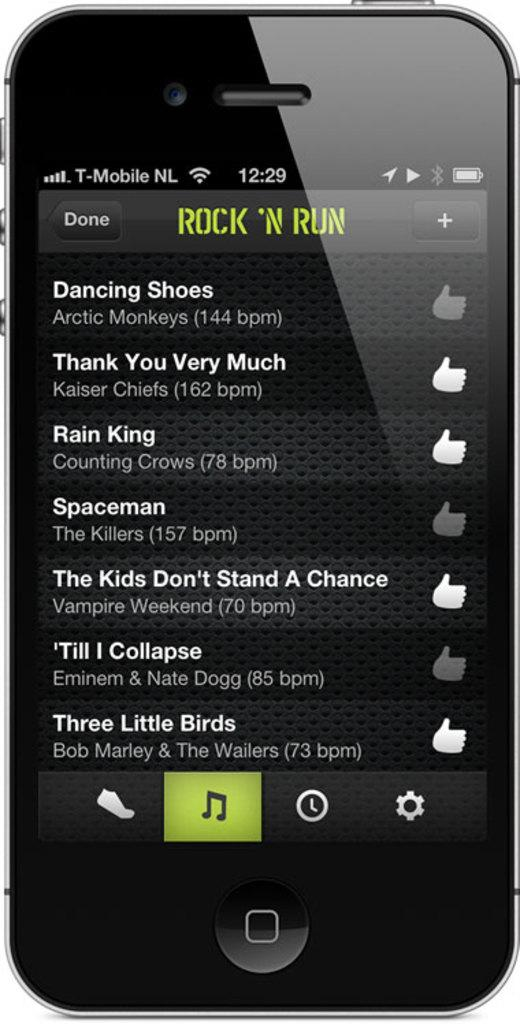<image>
Give a short and clear explanation of the subsequent image. The front of a cell phone listing songs like Three little Birds. 